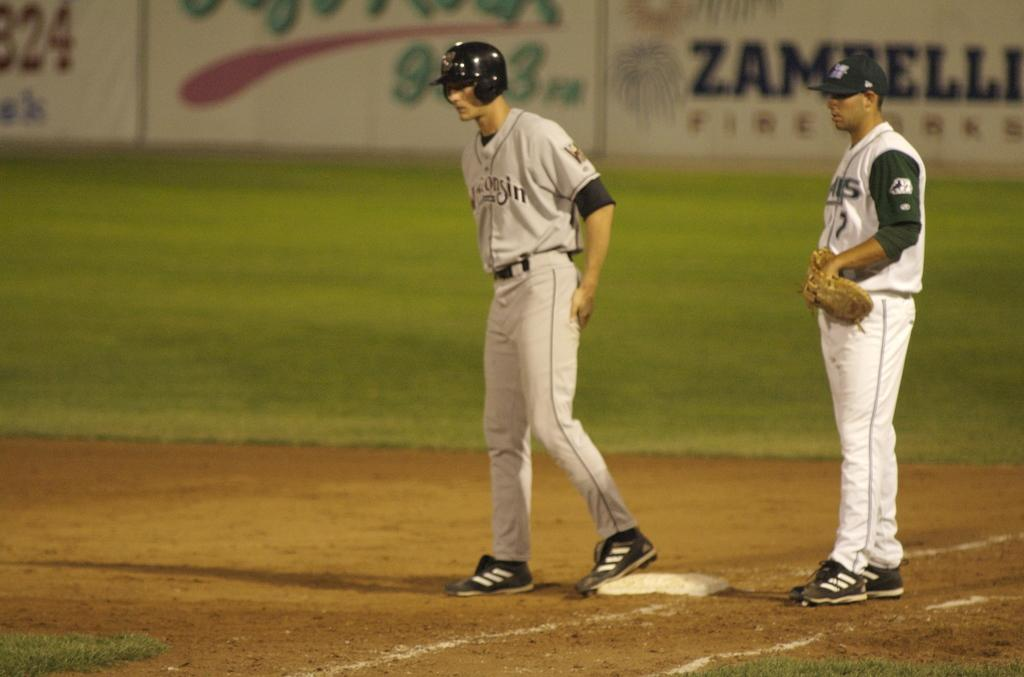<image>
Share a concise interpretation of the image provided. A Wisconsin baseball player stands on first base. 